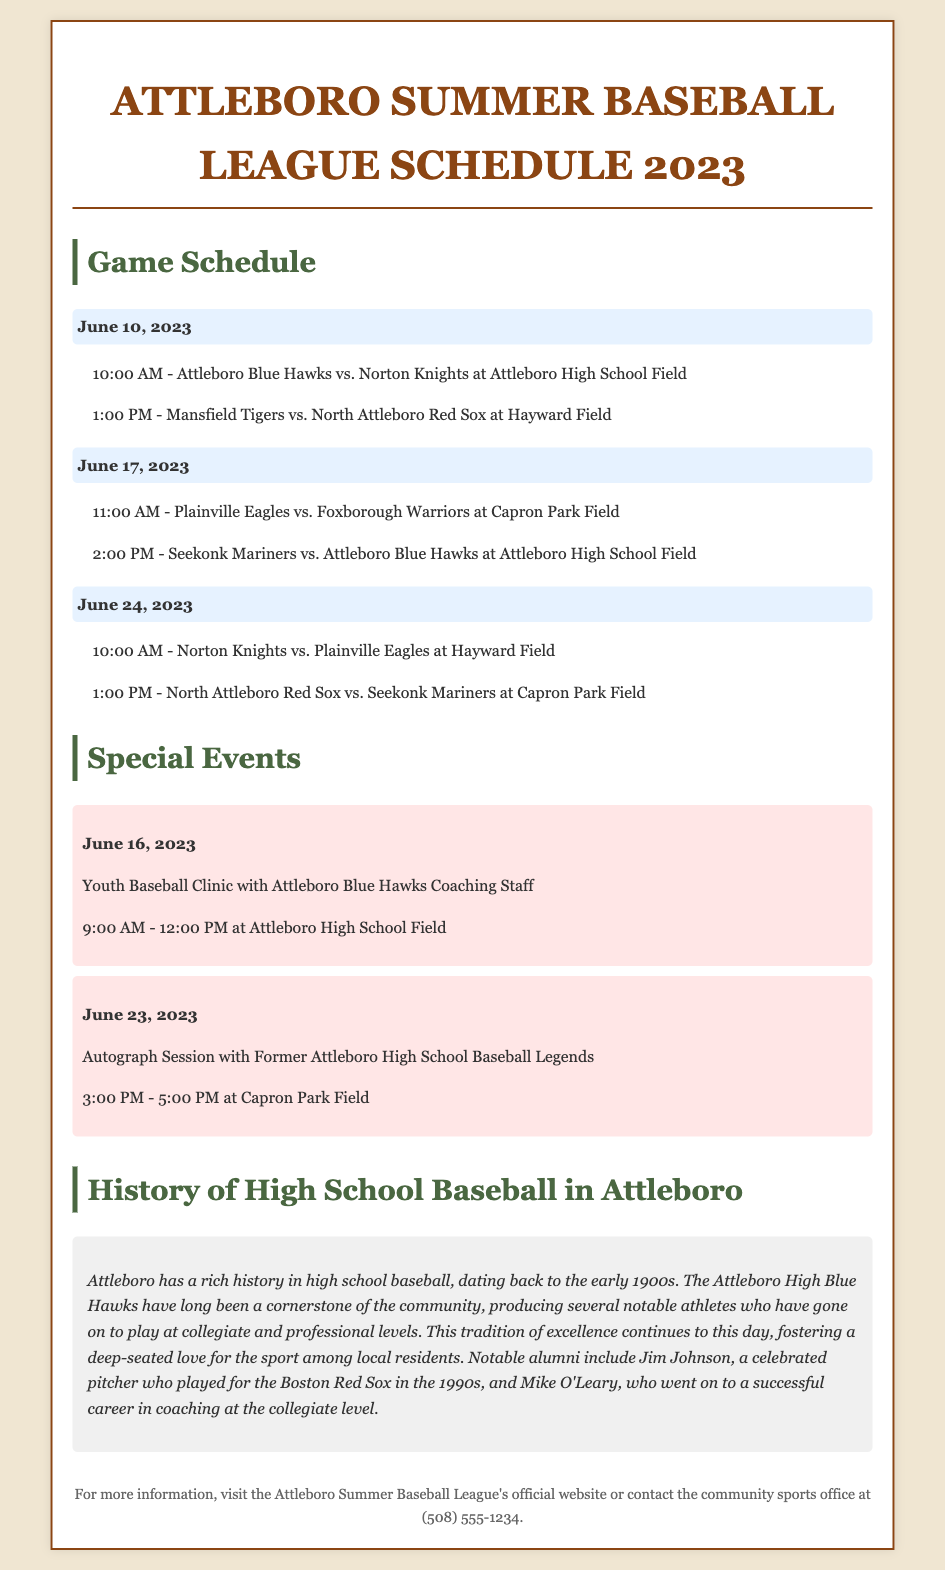What is the date of the first game? The first game is scheduled for June 10, 2023.
Answer: June 10, 2023 How many teams are participating in the league? The document mentions six teams: Attleboro Blue Hawks, Norton Knights, Mansfield Tigers, North Attleboro Red Sox, Plainville Eagles, and Seekonk Mariners.
Answer: Six teams What time does the Attleboro Blue Hawks vs. Norton Knights game start? The game between Attleboro Blue Hawks and Norton Knights starts at 10:00 AM.
Answer: 10:00 AM What special event is scheduled for June 23, 2023? On June 23, there is an autograph session with former Attleboro High School baseball legends.
Answer: Autograph session Who is a notable alumni mentioned in the history section? The document mentions Jim Johnson as a notable alumnus.
Answer: Jim Johnson What is the location of the Youth Baseball Clinic? The Youth Baseball Clinic is held at Attleboro High School Field.
Answer: Attleboro High School Field What is the starting time for the game between Seekonk Mariners and Attleboro Blue Hawks? The game starts at 2:00 PM.
Answer: 2:00 PM When was the Attleboro High Blue Hawks baseball program established? The text states that the program has been around since the early 1900s.
Answer: Early 1900s 